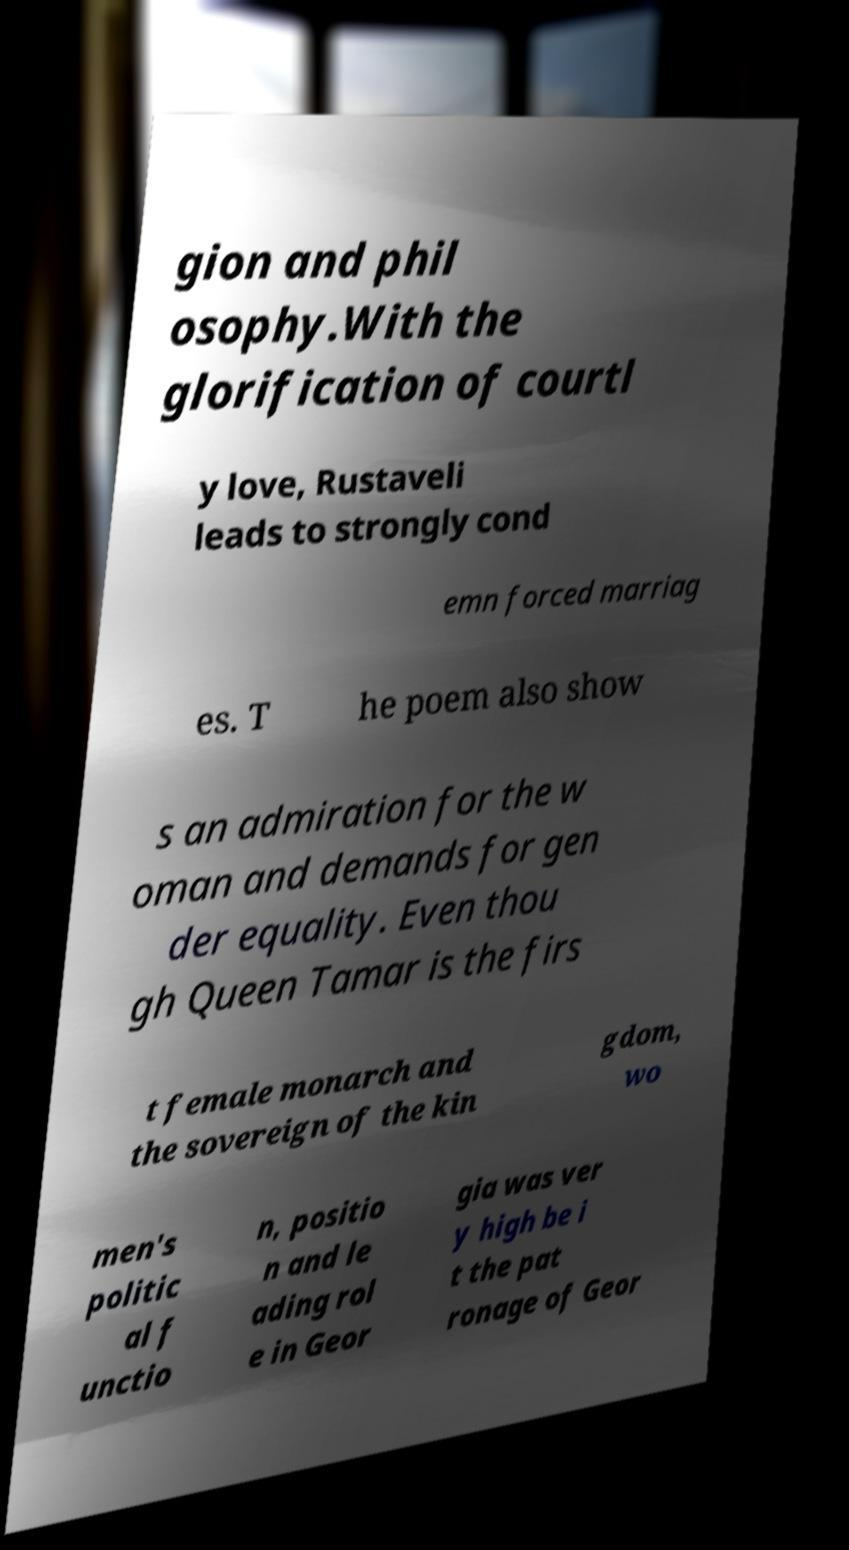Can you read and provide the text displayed in the image?This photo seems to have some interesting text. Can you extract and type it out for me? gion and phil osophy.With the glorification of courtl y love, Rustaveli leads to strongly cond emn forced marriag es. T he poem also show s an admiration for the w oman and demands for gen der equality. Even thou gh Queen Tamar is the firs t female monarch and the sovereign of the kin gdom, wo men's politic al f unctio n, positio n and le ading rol e in Geor gia was ver y high be i t the pat ronage of Geor 